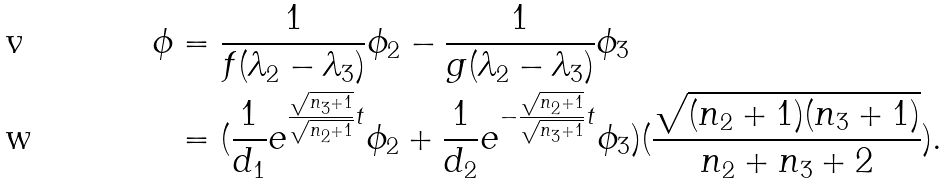Convert formula to latex. <formula><loc_0><loc_0><loc_500><loc_500>\phi & = \frac { 1 } { f ( \lambda _ { 2 } - \lambda _ { 3 } ) } \phi _ { 2 } - \frac { 1 } { g ( \lambda _ { 2 } - \lambda _ { 3 } ) } \phi _ { 3 } \\ & = ( \frac { 1 } { d _ { 1 } } e ^ { \frac { \sqrt { n _ { 3 } + 1 } } { \sqrt { n _ { 2 } + 1 } } t } \phi _ { 2 } + \frac { 1 } { d _ { 2 } } e ^ { - \frac { \sqrt { n _ { 2 } + 1 } } { \sqrt { n _ { 3 } + 1 } } t } \phi _ { 3 } ) ( \frac { \sqrt { ( n _ { 2 } + 1 ) ( n _ { 3 } + 1 ) } } { n _ { 2 } + n _ { 3 } + 2 } ) .</formula> 